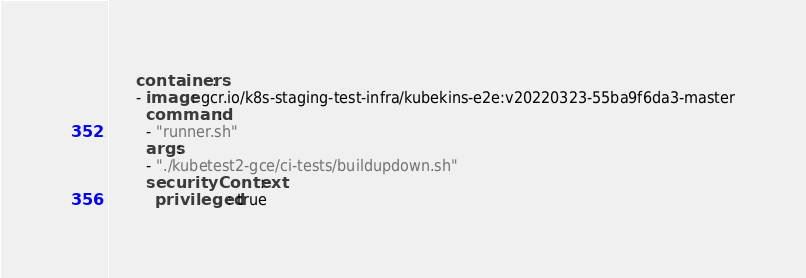Convert code to text. <code><loc_0><loc_0><loc_500><loc_500><_YAML_>      containers:
      - image: gcr.io/k8s-staging-test-infra/kubekins-e2e:v20220323-55ba9f6da3-master
        command:
        - "runner.sh"
        args:
        - "./kubetest2-gce/ci-tests/buildupdown.sh"
        securityContext:
          privileged: true
</code> 